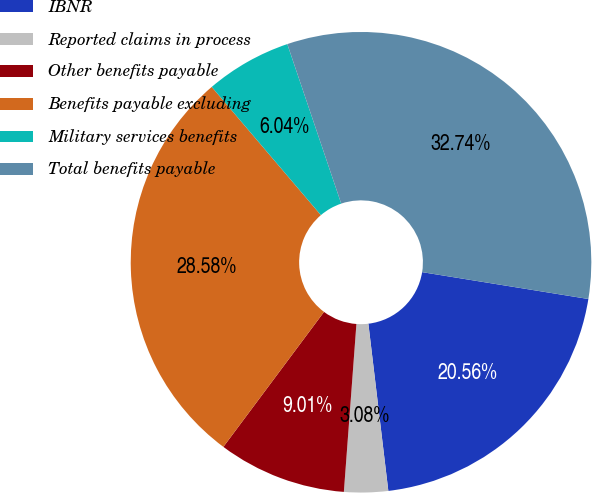Convert chart to OTSL. <chart><loc_0><loc_0><loc_500><loc_500><pie_chart><fcel>IBNR<fcel>Reported claims in process<fcel>Other benefits payable<fcel>Benefits payable excluding<fcel>Military services benefits<fcel>Total benefits payable<nl><fcel>20.56%<fcel>3.08%<fcel>9.01%<fcel>28.58%<fcel>6.04%<fcel>32.74%<nl></chart> 